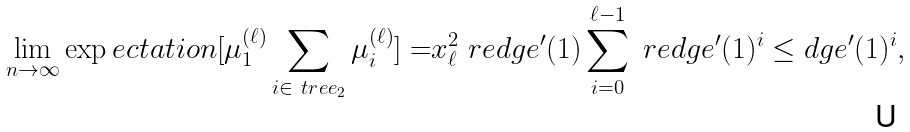<formula> <loc_0><loc_0><loc_500><loc_500>\lim _ { n \rightarrow \infty } \exp e c t a t i o n [ \mu _ { 1 } ^ { ( \ell ) } \sum _ { i \in \ t r e e _ { 2 } } \mu _ { i } ^ { ( \ell ) } ] = & x _ { \ell } ^ { 2 } \ r e d g e ^ { \prime } ( 1 ) \sum _ { i = 0 } ^ { \ell - 1 } \ r e d g e ^ { \prime } ( 1 ) ^ { i } \leq d g e ^ { \prime } ( 1 ) ^ { i } ,</formula> 